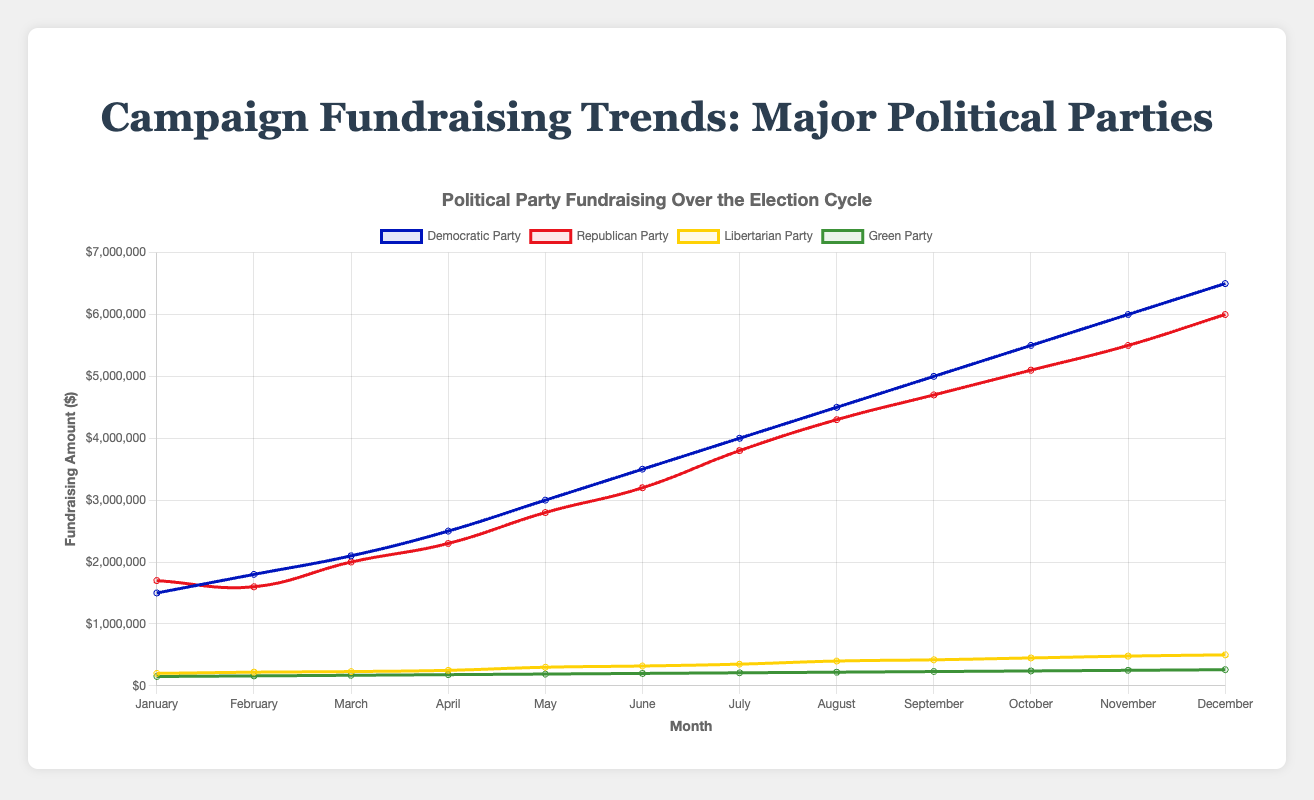What is the total fundraising amount for the Democratic Party over the year? Sum the monthly fundraising amounts for the Democratic Party: (1500000 + 1800000 + 2100000 + 2500000 + 3000000 + 3500000 + 4000000 + 4500000 + 5000000 + 5500000 + 6000000 + 6500000) = 45900000
Answer: 45900000 Which party raised the most funds in December? Compare the fundraising amounts for all parties in December. The Democratic Party raised $6500000, the Republican Party raised $6000000, the Libertarian Party raised $500000, and the Green Party raised $260000. The Democratic Party has the highest amount.
Answer: Democratic Party Between which two months did the Republican Party see the greatest increase in fundraising? Calculate the month-to-month increase for the Republican Party and compare. The major increases are: January to February (-100000), February to March (400000), March to April (300000), April to May (500000), May to June (400000), June to July (600000). The largest increase is between June and July.
Answer: June to July Is there any month where all parties' fundraising amounts increased compared to the previous month? Check the month-to-month changes for each party and see if there is any common month where all values increase compared to the previous month. In May (comparing April), all values for Democratic Party, Republican Party, Libertarian Party, and Green Party increased.
Answer: May What is the average monthly fundraising amount for the Libertarian Party? Sum the monthly fundraising amounts for the Libertarian Party and divide by 12: (200000 + 220000 + 230000 + 250000 + 300000 + 320000 + 350000 + 400000 + 420000 + 450000 + 480000 + 500000) = 4120000. Average is 4120000 / 12 = 343333.33
Answer: 343333.33 Which party showed the most consistent (least variable) fundraising over the year? The Green Party shows a steadily increasing but very consistent pattern with small increments each month. Compare standard deviation, but visually the Green Party has the least variability.
Answer: Green Party 